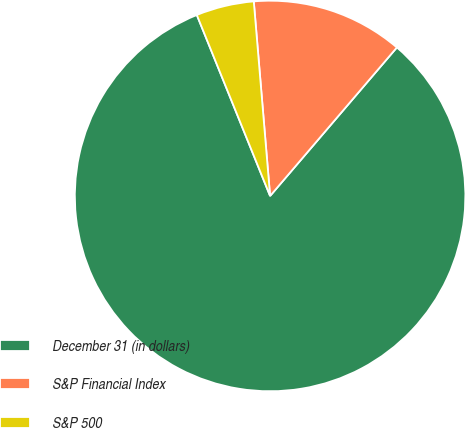Convert chart to OTSL. <chart><loc_0><loc_0><loc_500><loc_500><pie_chart><fcel>December 31 (in dollars)<fcel>S&P Financial Index<fcel>S&P 500<nl><fcel>82.63%<fcel>12.58%<fcel>4.79%<nl></chart> 